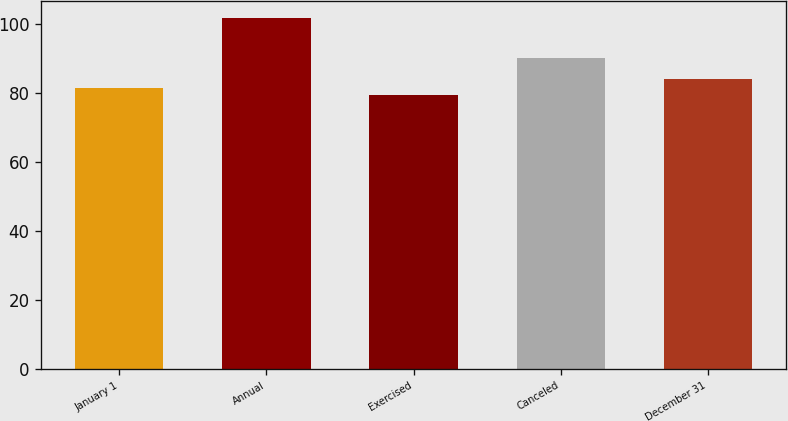Convert chart. <chart><loc_0><loc_0><loc_500><loc_500><bar_chart><fcel>January 1<fcel>Annual<fcel>Exercised<fcel>Canceled<fcel>December 31<nl><fcel>81.48<fcel>101.55<fcel>79.25<fcel>89.92<fcel>83.84<nl></chart> 